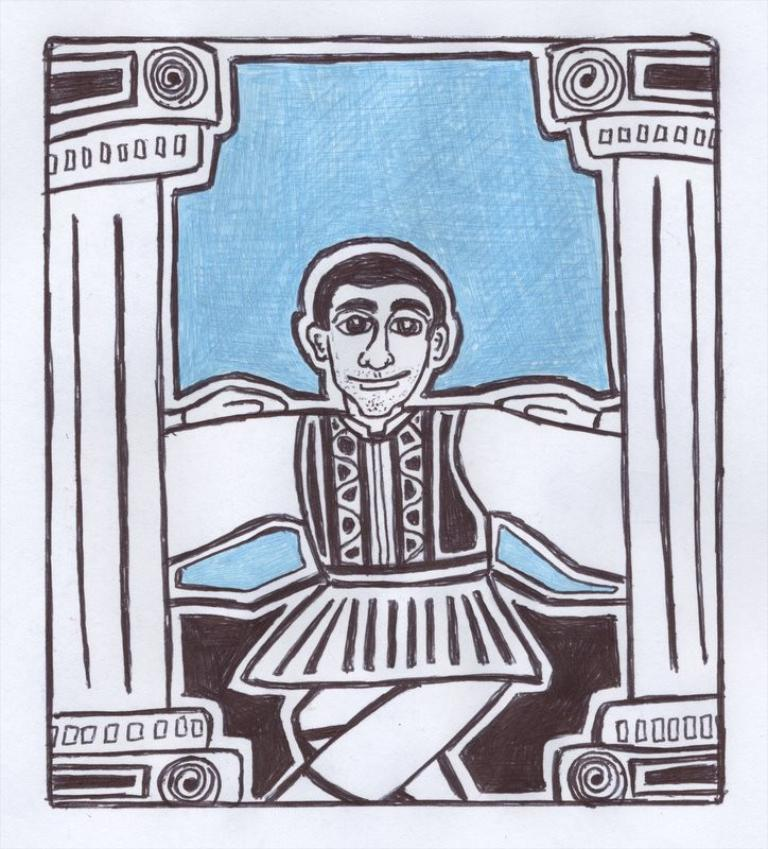What is featured on the poster in the image? The poster contains an image of a person and pillars. Can you describe the image of the person on the poster? Unfortunately, the details of the person's image on the poster cannot be determined from the provided facts. What else is present on the poster besides the image of the person? The poster also contains pillars. What type of needle is being used by the person on the poster? There is no needle present in the image, as the poster only contains an image of a person and pillars. 